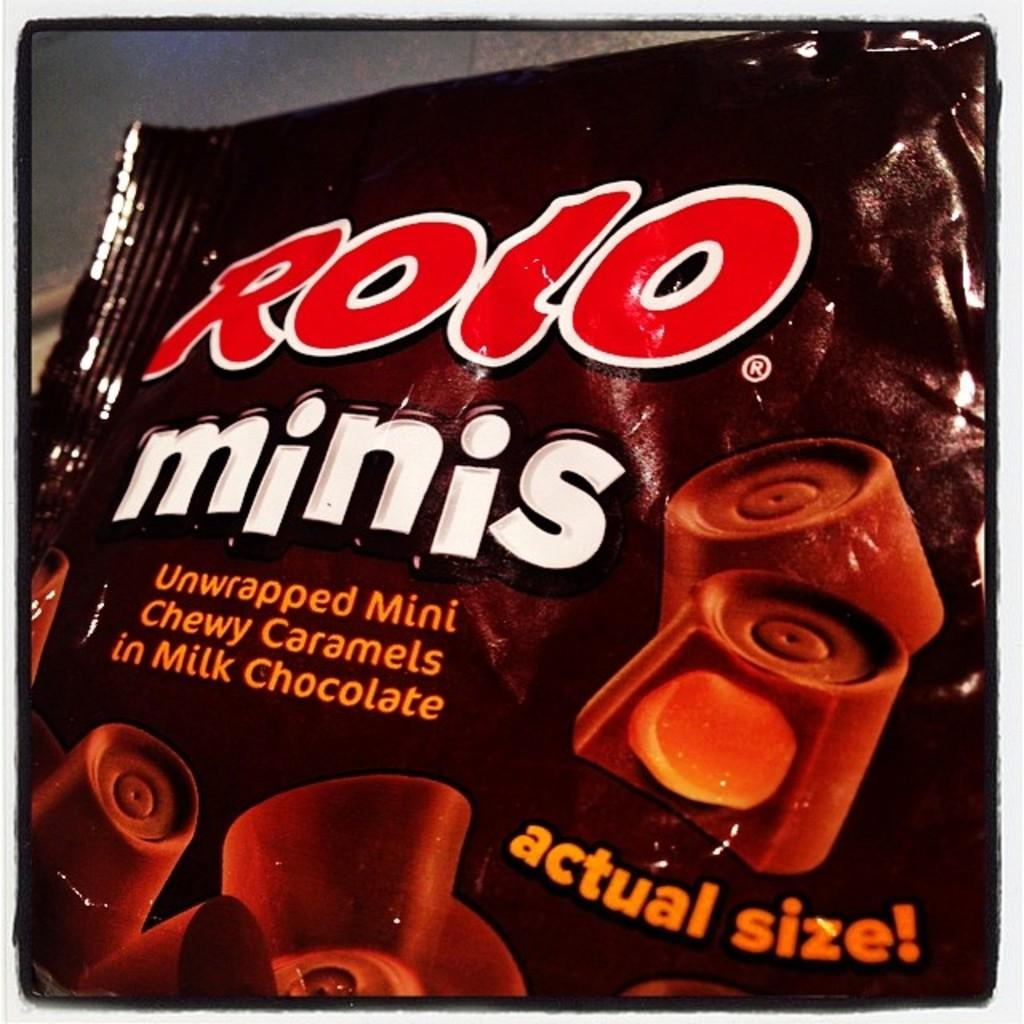What type of chocolate is featured in the image? There is a milk chocolate pack in the image. What information is provided on the milk chocolate pack? The milk chocolate pack has text on it. How is the image visually framed? The image has borders. Can you see your dad fishing by the river in the image? There is no reference to a dad, fishing, or a river in the image; it features a milk chocolate pack with text on it. 